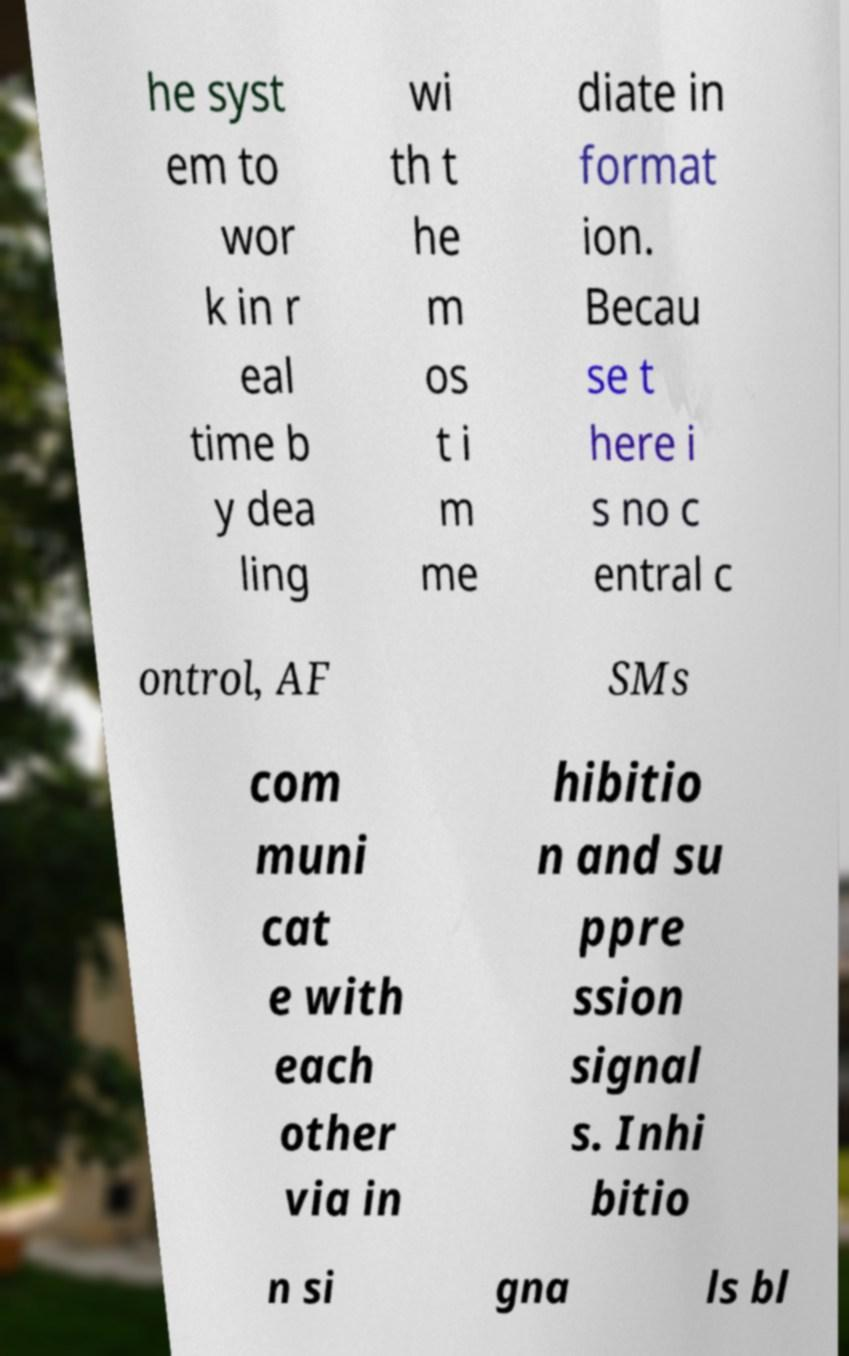Please read and relay the text visible in this image. What does it say? he syst em to wor k in r eal time b y dea ling wi th t he m os t i m me diate in format ion. Becau se t here i s no c entral c ontrol, AF SMs com muni cat e with each other via in hibitio n and su ppre ssion signal s. Inhi bitio n si gna ls bl 